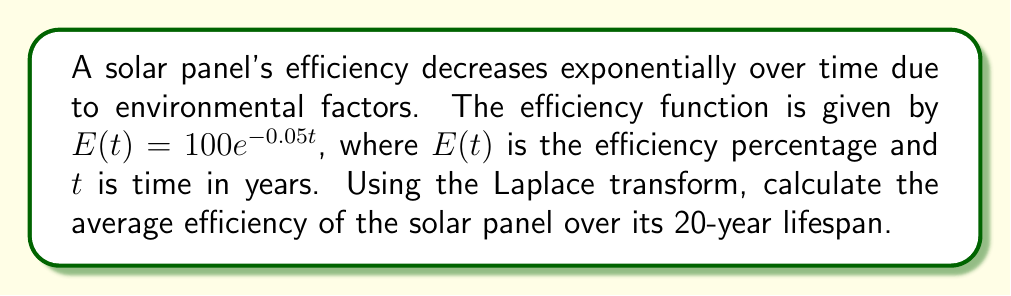Can you solve this math problem? To solve this problem, we'll use the Laplace transform to find the average efficiency over time. Here's the step-by-step process:

1) The average efficiency over time T is given by:

   $$\bar{E} = \frac{1}{T} \int_0^T E(t) dt$$

2) We can use the Laplace transform to simplify this calculation. The Laplace transform of $E(t)$ is:

   $$\mathcal{L}\{E(t)\} = \int_0^\infty E(t)e^{-st}dt = \frac{100}{s+0.05}$$

3) To find the integral of $E(t)$ from 0 to T, we can use the following property:

   $$\int_0^T E(t)dt = \frac{1}{s}\mathcal{L}\{E(t)\}\bigg|_{s=0} - \frac{1}{s}\mathcal{L}\{E(t)\}e^{-sT}\bigg|_{s=0}$$

4) Substituting our Laplace transform:

   $$\int_0^T E(t)dt = \frac{100}{s(s+0.05)}\bigg|_{s=0} - \frac{100e^{-sT}}{s(s+0.05)}\bigg|_{s=0}$$

5) Evaluating the limit as s approaches 0:

   $$\int_0^T E(t)dt = \frac{100}{0.05} - \frac{100e^{-0.05T}}{0.05} = 2000(1-e^{-0.05T})$$

6) Now, we can calculate the average efficiency:

   $$\bar{E} = \frac{1}{T} \int_0^T E(t) dt = \frac{2000(1-e^{-0.05T})}{T}$$

7) Substituting T = 20 years:

   $$\bar{E} = \frac{2000(1-e^{-0.05(20)})}{20} = \frac{2000(1-e^{-1})}{20} \approx 63.21$$

Thus, the average efficiency over the 20-year lifespan is approximately 63.21%.
Answer: The average efficiency of the solar panel over its 20-year lifespan is approximately 63.21%. 